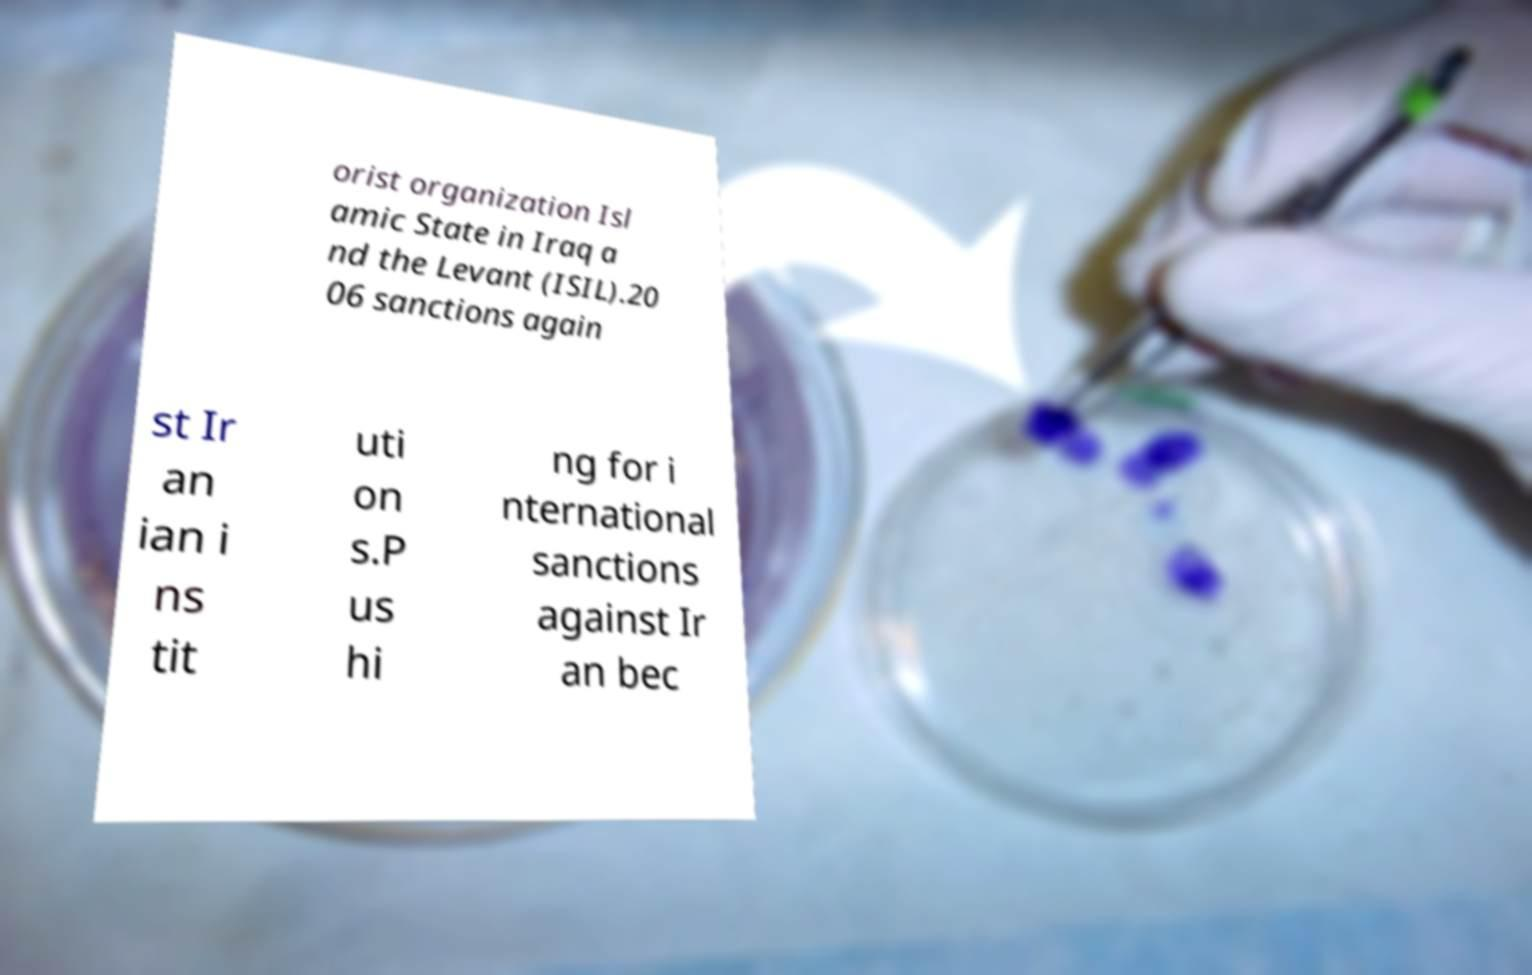Can you read and provide the text displayed in the image?This photo seems to have some interesting text. Can you extract and type it out for me? orist organization Isl amic State in Iraq a nd the Levant (ISIL).20 06 sanctions again st Ir an ian i ns tit uti on s.P us hi ng for i nternational sanctions against Ir an bec 